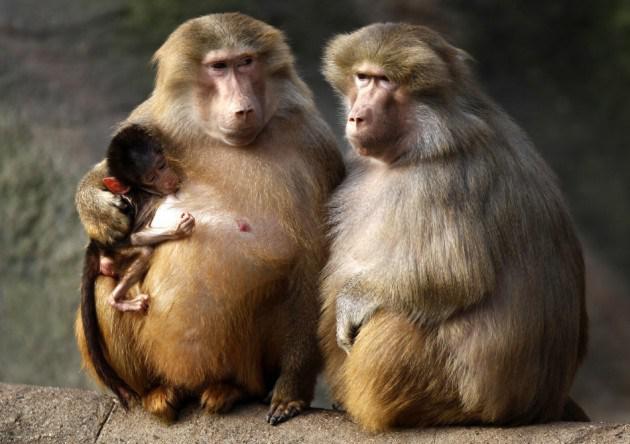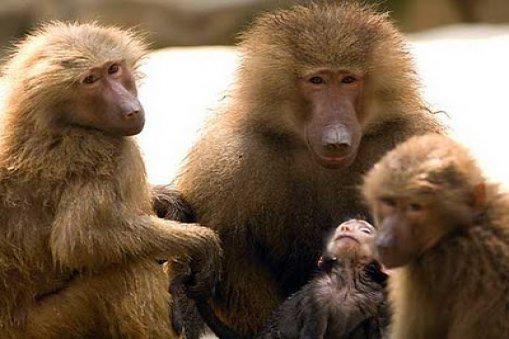The first image is the image on the left, the second image is the image on the right. Analyze the images presented: Is the assertion "The combined images include no more than ten baboons and include at least two baby baboons." valid? Answer yes or no. Yes. The first image is the image on the left, the second image is the image on the right. For the images displayed, is the sentence "There are exactly seven monkeys." factually correct? Answer yes or no. Yes. 